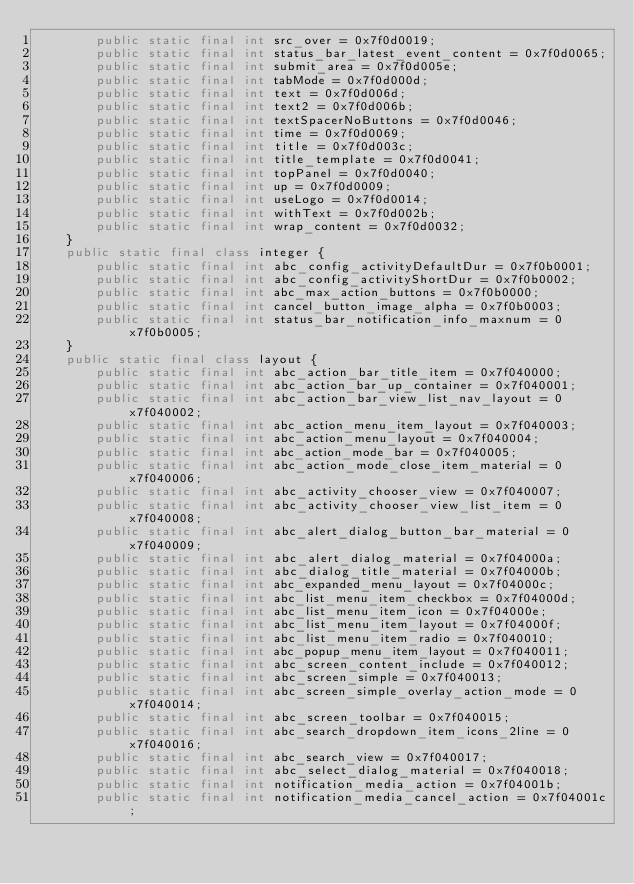Convert code to text. <code><loc_0><loc_0><loc_500><loc_500><_Java_>		public static final int src_over = 0x7f0d0019;
		public static final int status_bar_latest_event_content = 0x7f0d0065;
		public static final int submit_area = 0x7f0d005e;
		public static final int tabMode = 0x7f0d000d;
		public static final int text = 0x7f0d006d;
		public static final int text2 = 0x7f0d006b;
		public static final int textSpacerNoButtons = 0x7f0d0046;
		public static final int time = 0x7f0d0069;
		public static final int title = 0x7f0d003c;
		public static final int title_template = 0x7f0d0041;
		public static final int topPanel = 0x7f0d0040;
		public static final int up = 0x7f0d0009;
		public static final int useLogo = 0x7f0d0014;
		public static final int withText = 0x7f0d002b;
		public static final int wrap_content = 0x7f0d0032;
	}
	public static final class integer {
		public static final int abc_config_activityDefaultDur = 0x7f0b0001;
		public static final int abc_config_activityShortDur = 0x7f0b0002;
		public static final int abc_max_action_buttons = 0x7f0b0000;
		public static final int cancel_button_image_alpha = 0x7f0b0003;
		public static final int status_bar_notification_info_maxnum = 0x7f0b0005;
	}
	public static final class layout {
		public static final int abc_action_bar_title_item = 0x7f040000;
		public static final int abc_action_bar_up_container = 0x7f040001;
		public static final int abc_action_bar_view_list_nav_layout = 0x7f040002;
		public static final int abc_action_menu_item_layout = 0x7f040003;
		public static final int abc_action_menu_layout = 0x7f040004;
		public static final int abc_action_mode_bar = 0x7f040005;
		public static final int abc_action_mode_close_item_material = 0x7f040006;
		public static final int abc_activity_chooser_view = 0x7f040007;
		public static final int abc_activity_chooser_view_list_item = 0x7f040008;
		public static final int abc_alert_dialog_button_bar_material = 0x7f040009;
		public static final int abc_alert_dialog_material = 0x7f04000a;
		public static final int abc_dialog_title_material = 0x7f04000b;
		public static final int abc_expanded_menu_layout = 0x7f04000c;
		public static final int abc_list_menu_item_checkbox = 0x7f04000d;
		public static final int abc_list_menu_item_icon = 0x7f04000e;
		public static final int abc_list_menu_item_layout = 0x7f04000f;
		public static final int abc_list_menu_item_radio = 0x7f040010;
		public static final int abc_popup_menu_item_layout = 0x7f040011;
		public static final int abc_screen_content_include = 0x7f040012;
		public static final int abc_screen_simple = 0x7f040013;
		public static final int abc_screen_simple_overlay_action_mode = 0x7f040014;
		public static final int abc_screen_toolbar = 0x7f040015;
		public static final int abc_search_dropdown_item_icons_2line = 0x7f040016;
		public static final int abc_search_view = 0x7f040017;
		public static final int abc_select_dialog_material = 0x7f040018;
		public static final int notification_media_action = 0x7f04001b;
		public static final int notification_media_cancel_action = 0x7f04001c;</code> 